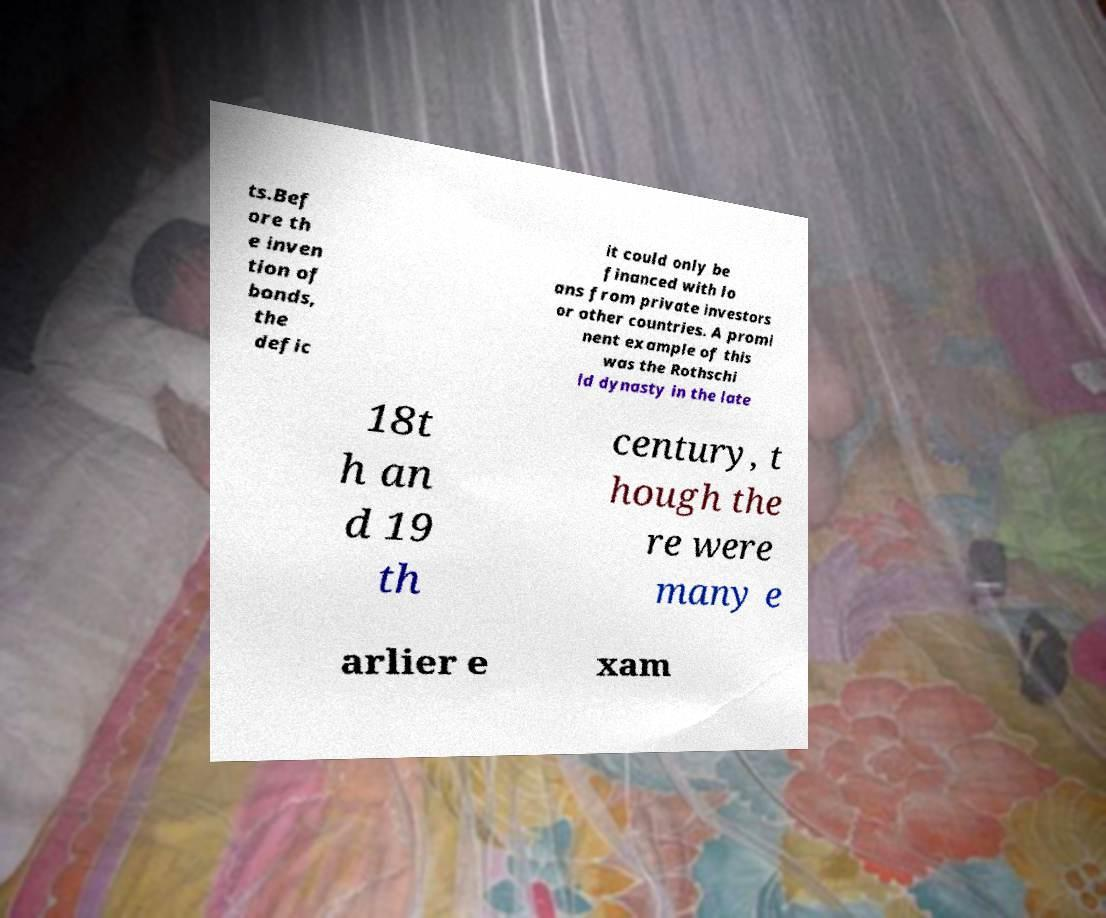There's text embedded in this image that I need extracted. Can you transcribe it verbatim? ts.Bef ore th e inven tion of bonds, the defic it could only be financed with lo ans from private investors or other countries. A promi nent example of this was the Rothschi ld dynasty in the late 18t h an d 19 th century, t hough the re were many e arlier e xam 